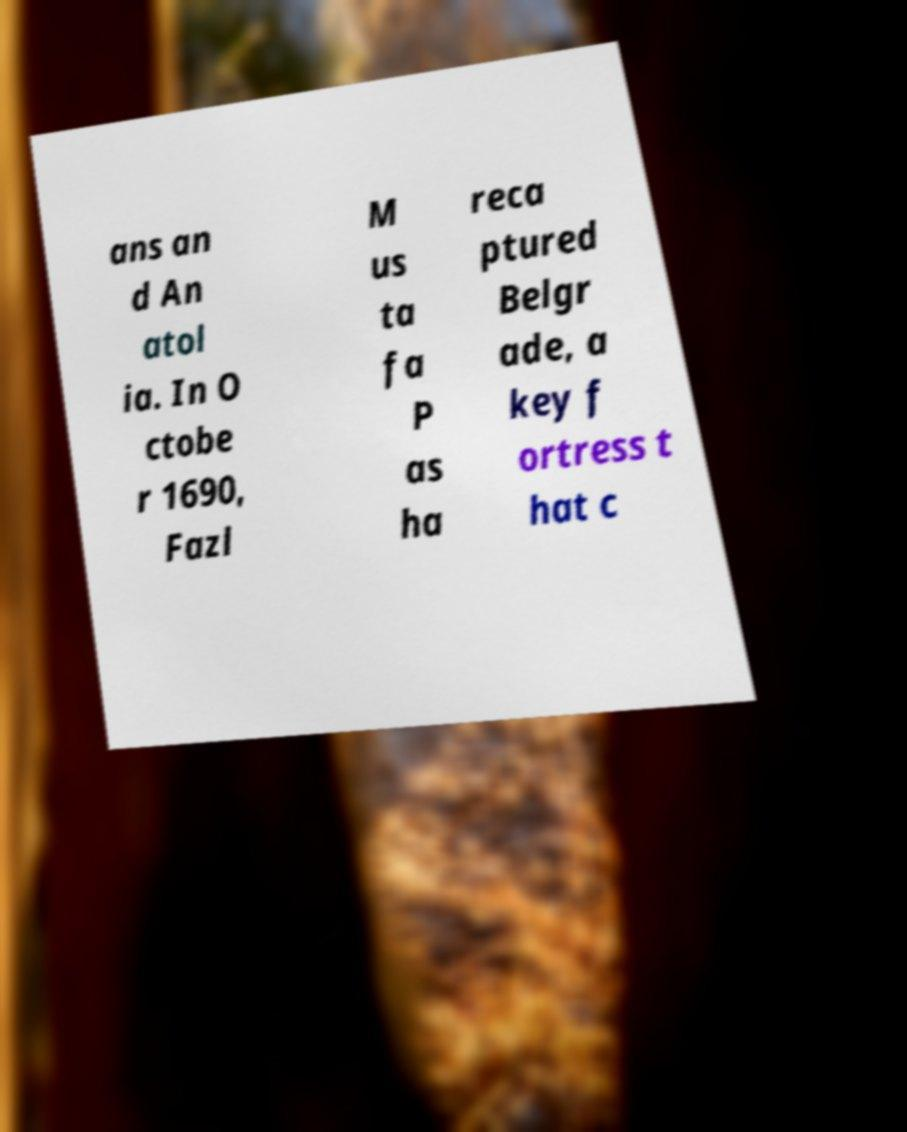Can you accurately transcribe the text from the provided image for me? ans an d An atol ia. In O ctobe r 1690, Fazl M us ta fa P as ha reca ptured Belgr ade, a key f ortress t hat c 